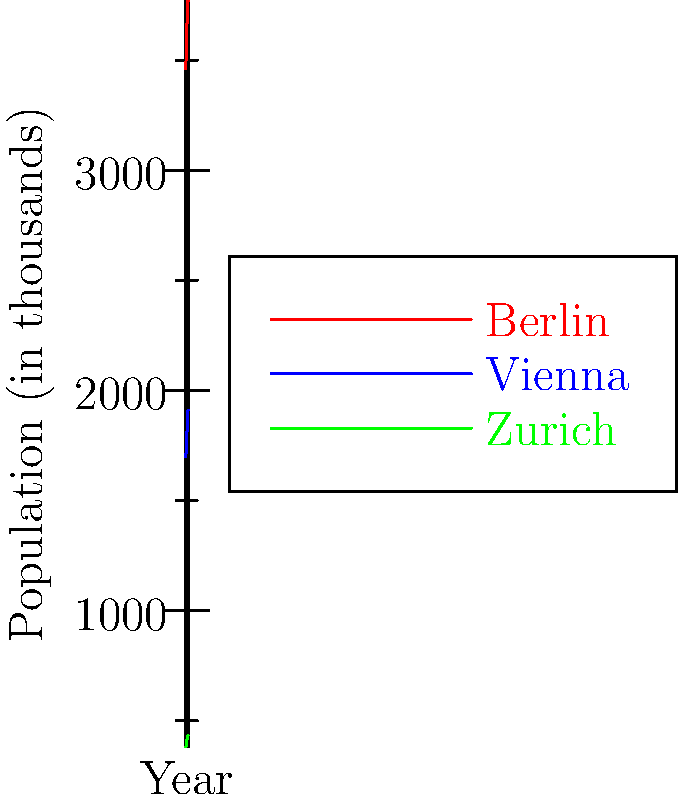Based on the line graph showing population growth in three major German-speaking cities from 2010 to 2020, which city experienced the highest percentage increase in population during this period? To determine which city had the highest percentage increase in population, we need to calculate the percentage change for each city from 2010 to 2020:

1. Berlin:
   2010 population: 3460.7 thousand
   2020 population: 3769.5 thousand
   Percentage change = $(3769.5 - 3460.7) / 3460.7 \times 100\% = 8.92\%$

2. Vienna:
   2010 population: 1698.8 thousand
   2020 population: 1911.2 thousand
   Percentage change = $(1911.2 - 1698.8) / 1698.8 \times 100\% = 12.50\%$

3. Zurich:
   2010 population: 380.5 thousand
   2020 population: 434.0 thousand
   Percentage change = $(434.0 - 380.5) / 380.5 \times 100\% = 14.06\%$

Comparing these percentages, we can see that Zurich had the highest percentage increase in population during this period.
Answer: Zurich 